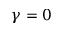<formula> <loc_0><loc_0><loc_500><loc_500>\gamma = 0</formula> 